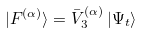Convert formula to latex. <formula><loc_0><loc_0><loc_500><loc_500>| F ^ { ( \alpha ) } \rangle = \bar { V } ^ { ( \alpha ) } _ { 3 } \, | \Psi _ { t } \rangle</formula> 